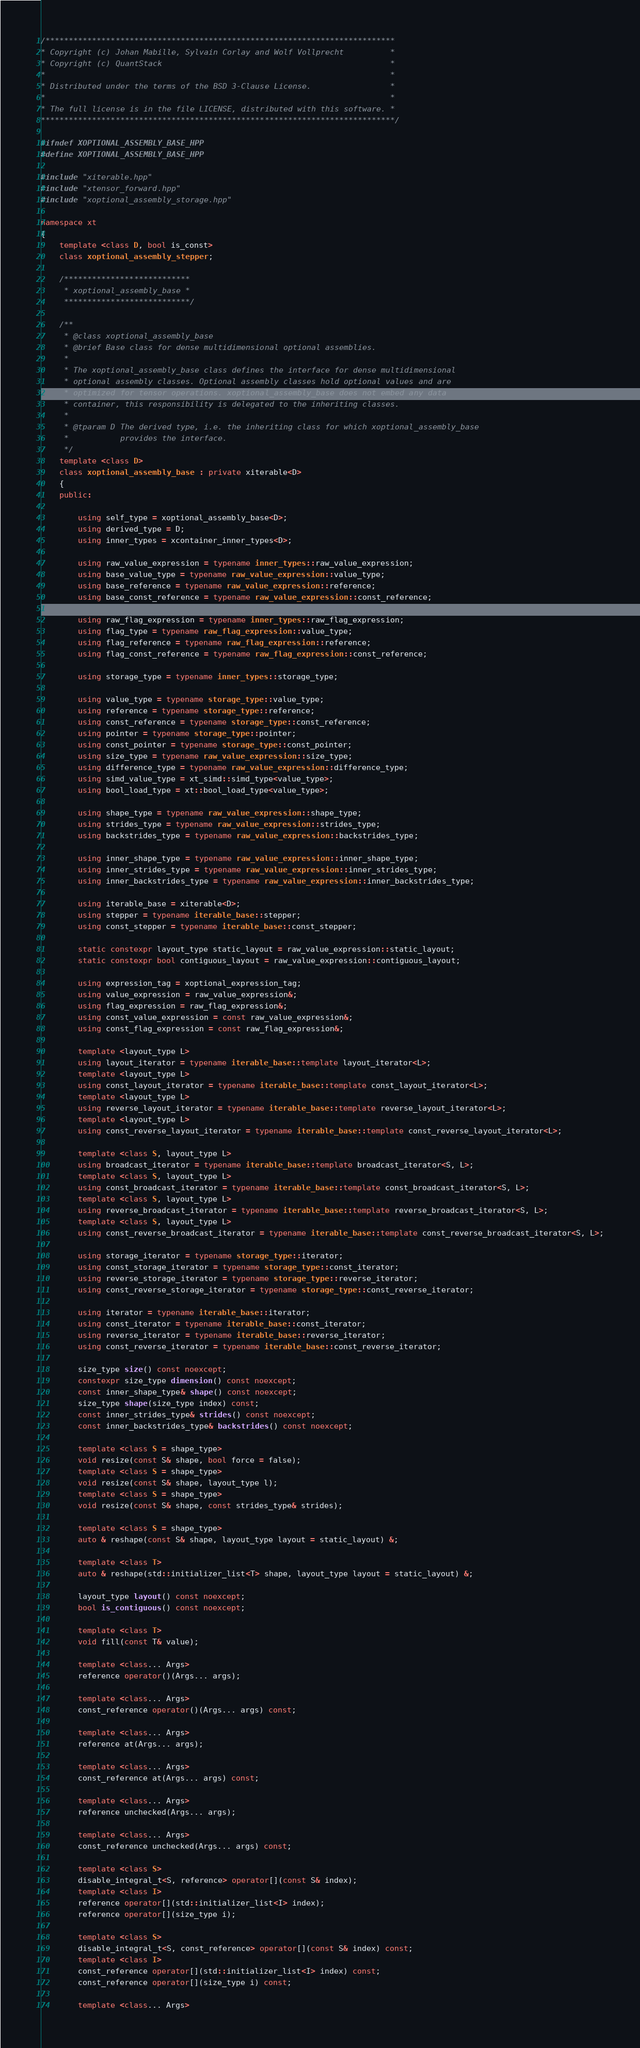<code> <loc_0><loc_0><loc_500><loc_500><_C++_>/***************************************************************************
* Copyright (c) Johan Mabille, Sylvain Corlay and Wolf Vollprecht          *
* Copyright (c) QuantStack                                                 *
*                                                                          *
* Distributed under the terms of the BSD 3-Clause License.                 *
*                                                                          *
* The full license is in the file LICENSE, distributed with this software. *
****************************************************************************/

#ifndef XOPTIONAL_ASSEMBLY_BASE_HPP
#define XOPTIONAL_ASSEMBLY_BASE_HPP

#include "xiterable.hpp"
#include "xtensor_forward.hpp"
#include "xoptional_assembly_storage.hpp"

namespace xt
{
    template <class D, bool is_const>
    class xoptional_assembly_stepper;

    /***************************
     * xoptional_assembly_base *
     ***************************/

    /**
     * @class xoptional_assembly_base
     * @brief Base class for dense multidimensional optional assemblies.
     *
     * The xoptional_assembly_base class defines the interface for dense multidimensional
     * optional assembly classes. Optional assembly classes hold optional values and are
     * optimized for tensor operations. xoptional_assembly_base does not embed any data
     * container, this responsibility is delegated to the inheriting classes.
     *
     * @tparam D The derived type, i.e. the inheriting class for which xoptional_assembly_base
     *           provides the interface.
     */
    template <class D>
    class xoptional_assembly_base : private xiterable<D>
    {
    public:

        using self_type = xoptional_assembly_base<D>;
        using derived_type = D;
        using inner_types = xcontainer_inner_types<D>;

        using raw_value_expression = typename inner_types::raw_value_expression;
        using base_value_type = typename raw_value_expression::value_type;
        using base_reference = typename raw_value_expression::reference;
        using base_const_reference = typename raw_value_expression::const_reference;

        using raw_flag_expression = typename inner_types::raw_flag_expression;
        using flag_type = typename raw_flag_expression::value_type;
        using flag_reference = typename raw_flag_expression::reference;
        using flag_const_reference = typename raw_flag_expression::const_reference;

        using storage_type = typename inner_types::storage_type;

        using value_type = typename storage_type::value_type;
        using reference = typename storage_type::reference;
        using const_reference = typename storage_type::const_reference;
        using pointer = typename storage_type::pointer;
        using const_pointer = typename storage_type::const_pointer;
        using size_type = typename raw_value_expression::size_type;
        using difference_type = typename raw_value_expression::difference_type;
        using simd_value_type = xt_simd::simd_type<value_type>;
        using bool_load_type = xt::bool_load_type<value_type>;

        using shape_type = typename raw_value_expression::shape_type;
        using strides_type = typename raw_value_expression::strides_type;
        using backstrides_type = typename raw_value_expression::backstrides_type;

        using inner_shape_type = typename raw_value_expression::inner_shape_type;
        using inner_strides_type = typename raw_value_expression::inner_strides_type;
        using inner_backstrides_type = typename raw_value_expression::inner_backstrides_type;

        using iterable_base = xiterable<D>;
        using stepper = typename iterable_base::stepper;
        using const_stepper = typename iterable_base::const_stepper;

        static constexpr layout_type static_layout = raw_value_expression::static_layout;
        static constexpr bool contiguous_layout = raw_value_expression::contiguous_layout;

        using expression_tag = xoptional_expression_tag;
        using value_expression = raw_value_expression&;
        using flag_expression = raw_flag_expression&;
        using const_value_expression = const raw_value_expression&;
        using const_flag_expression = const raw_flag_expression&;

        template <layout_type L>
        using layout_iterator = typename iterable_base::template layout_iterator<L>;
        template <layout_type L>
        using const_layout_iterator = typename iterable_base::template const_layout_iterator<L>;
        template <layout_type L>
        using reverse_layout_iterator = typename iterable_base::template reverse_layout_iterator<L>;
        template <layout_type L>
        using const_reverse_layout_iterator = typename iterable_base::template const_reverse_layout_iterator<L>;

        template <class S, layout_type L>
        using broadcast_iterator = typename iterable_base::template broadcast_iterator<S, L>;
        template <class S, layout_type L>
        using const_broadcast_iterator = typename iterable_base::template const_broadcast_iterator<S, L>;
        template <class S, layout_type L>
        using reverse_broadcast_iterator = typename iterable_base::template reverse_broadcast_iterator<S, L>;
        template <class S, layout_type L>
        using const_reverse_broadcast_iterator = typename iterable_base::template const_reverse_broadcast_iterator<S, L>;

        using storage_iterator = typename storage_type::iterator;
        using const_storage_iterator = typename storage_type::const_iterator;
        using reverse_storage_iterator = typename storage_type::reverse_iterator;
        using const_reverse_storage_iterator = typename storage_type::const_reverse_iterator;

        using iterator = typename iterable_base::iterator;
        using const_iterator = typename iterable_base::const_iterator;
        using reverse_iterator = typename iterable_base::reverse_iterator;
        using const_reverse_iterator = typename iterable_base::const_reverse_iterator;

        size_type size() const noexcept;
        constexpr size_type dimension() const noexcept;
        const inner_shape_type& shape() const noexcept;
        size_type shape(size_type index) const;
        const inner_strides_type& strides() const noexcept;
        const inner_backstrides_type& backstrides() const noexcept;

        template <class S = shape_type>
        void resize(const S& shape, bool force = false);
        template <class S = shape_type>
        void resize(const S& shape, layout_type l);
        template <class S = shape_type>
        void resize(const S& shape, const strides_type& strides);

        template <class S = shape_type>
        auto & reshape(const S& shape, layout_type layout = static_layout) &;

        template <class T>
        auto & reshape(std::initializer_list<T> shape, layout_type layout = static_layout) &;

        layout_type layout() const noexcept;
        bool is_contiguous() const noexcept;

        template <class T>
        void fill(const T& value);

        template <class... Args>
        reference operator()(Args... args);

        template <class... Args>
        const_reference operator()(Args... args) const;

        template <class... Args>
        reference at(Args... args);

        template <class... Args>
        const_reference at(Args... args) const;

        template <class... Args>
        reference unchecked(Args... args);

        template <class... Args>
        const_reference unchecked(Args... args) const;

        template <class S>
        disable_integral_t<S, reference> operator[](const S& index);
        template <class I>
        reference operator[](std::initializer_list<I> index);
        reference operator[](size_type i);

        template <class S>
        disable_integral_t<S, const_reference> operator[](const S& index) const;
        template <class I>
        const_reference operator[](std::initializer_list<I> index) const;
        const_reference operator[](size_type i) const;

        template <class... Args></code> 